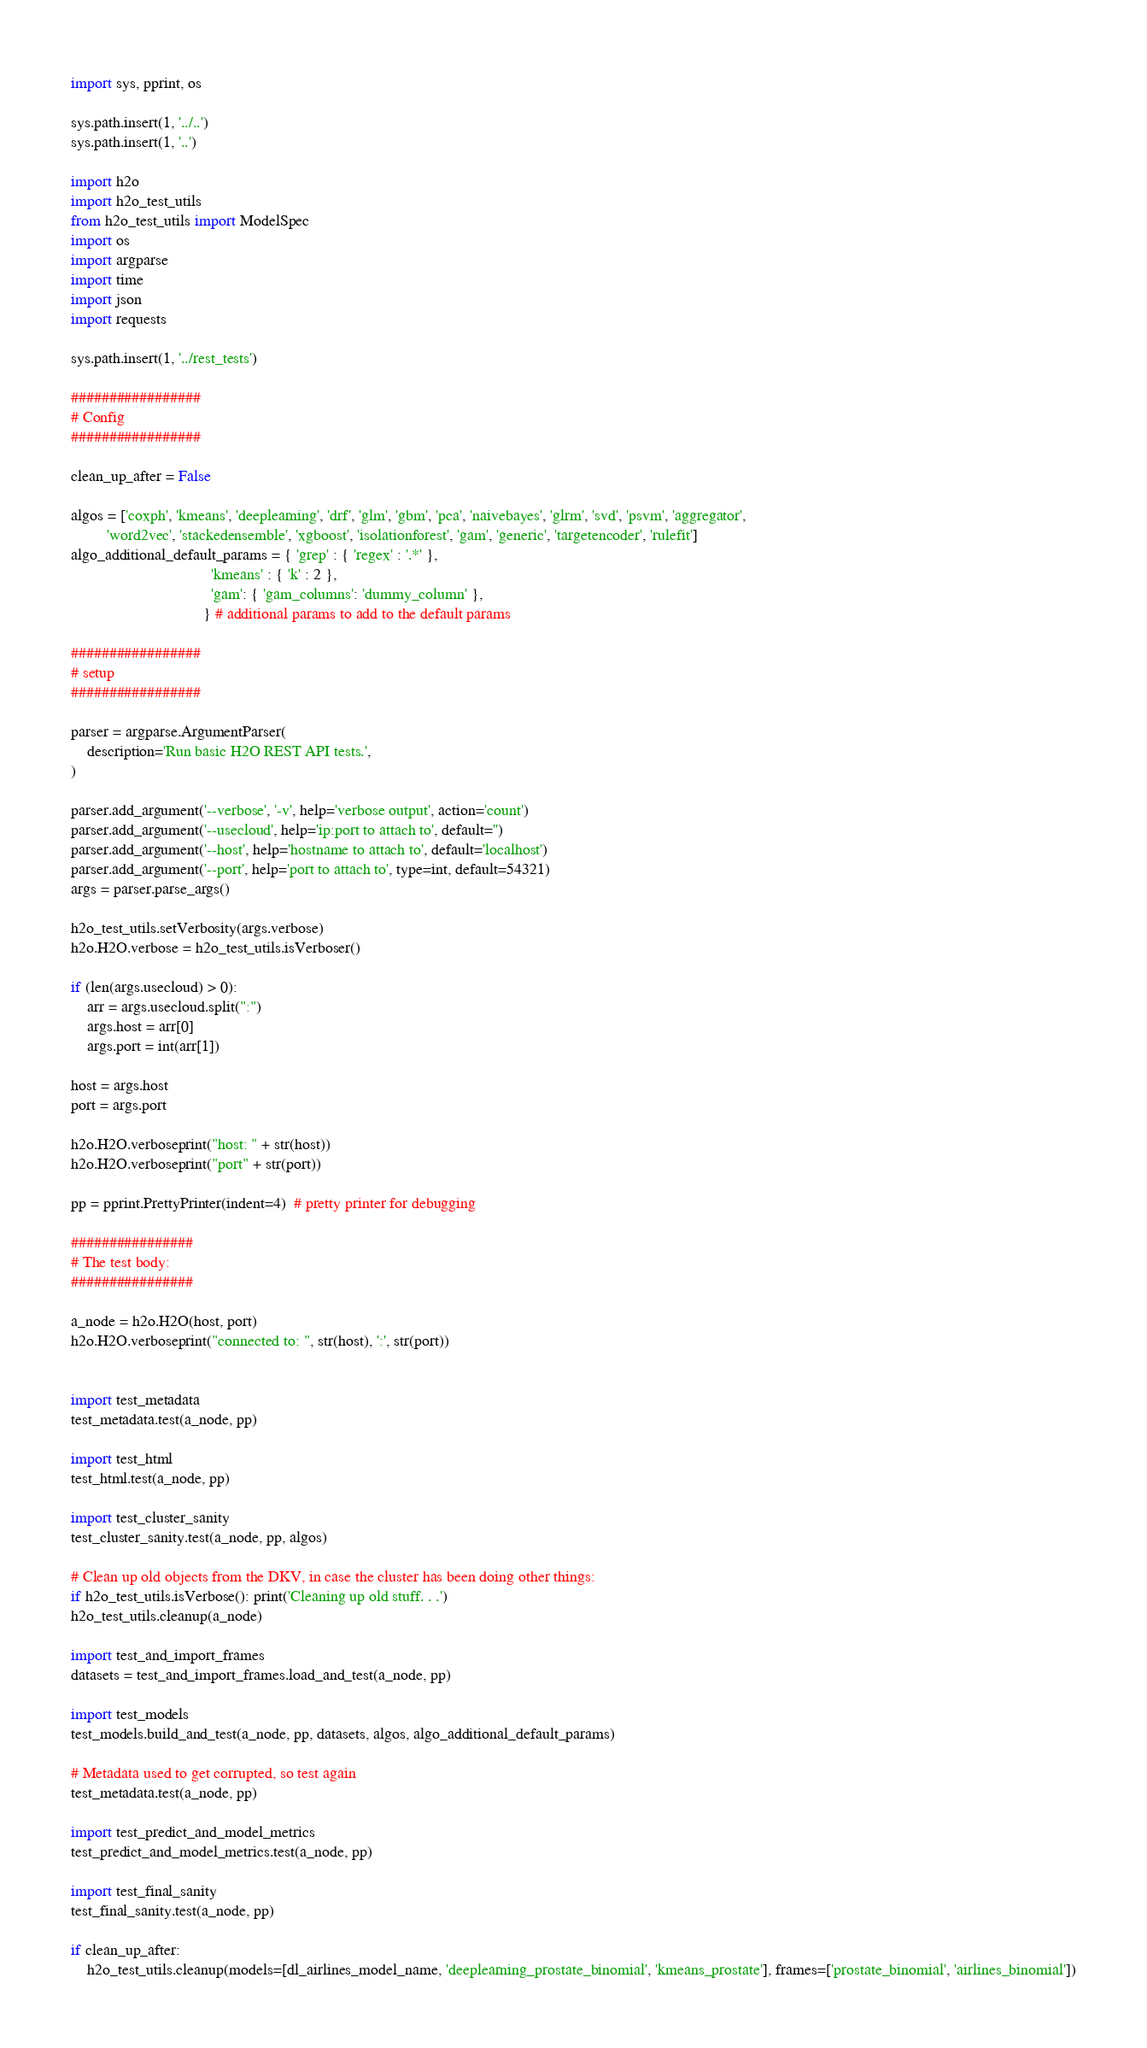<code> <loc_0><loc_0><loc_500><loc_500><_Python_>import sys, pprint, os

sys.path.insert(1, '../..')
sys.path.insert(1, '..')

import h2o
import h2o_test_utils
from h2o_test_utils import ModelSpec
import os
import argparse
import time
import json
import requests

sys.path.insert(1, '../rest_tests')

#################
# Config
#################

clean_up_after = False

algos = ['coxph', 'kmeans', 'deeplearning', 'drf', 'glm', 'gbm', 'pca', 'naivebayes', 'glrm', 'svd', 'psvm', 'aggregator',
         'word2vec', 'stackedensemble', 'xgboost', 'isolationforest', 'gam', 'generic', 'targetencoder', 'rulefit']
algo_additional_default_params = { 'grep' : { 'regex' : '.*' },
                                   'kmeans' : { 'k' : 2 },
                                   'gam': { 'gam_columns': 'dummy_column' },
                                 } # additional params to add to the default params

#################
# setup
#################

parser = argparse.ArgumentParser(
    description='Run basic H2O REST API tests.',
)

parser.add_argument('--verbose', '-v', help='verbose output', action='count')
parser.add_argument('--usecloud', help='ip:port to attach to', default='')
parser.add_argument('--host', help='hostname to attach to', default='localhost')
parser.add_argument('--port', help='port to attach to', type=int, default=54321)
args = parser.parse_args()

h2o_test_utils.setVerbosity(args.verbose)
h2o.H2O.verbose = h2o_test_utils.isVerboser()

if (len(args.usecloud) > 0):
    arr = args.usecloud.split(":")
    args.host = arr[0]
    args.port = int(arr[1])

host = args.host
port = args.port

h2o.H2O.verboseprint("host: " + str(host))
h2o.H2O.verboseprint("port" + str(port))

pp = pprint.PrettyPrinter(indent=4)  # pretty printer for debugging

################
# The test body:
################

a_node = h2o.H2O(host, port)
h2o.H2O.verboseprint("connected to: ", str(host), ':', str(port))


import test_metadata
test_metadata.test(a_node, pp)

import test_html
test_html.test(a_node, pp)

import test_cluster_sanity
test_cluster_sanity.test(a_node, pp, algos)

# Clean up old objects from the DKV, in case the cluster has been doing other things:
if h2o_test_utils.isVerbose(): print('Cleaning up old stuff. . .')
h2o_test_utils.cleanup(a_node)

import test_and_import_frames
datasets = test_and_import_frames.load_and_test(a_node, pp)

import test_models
test_models.build_and_test(a_node, pp, datasets, algos, algo_additional_default_params)

# Metadata used to get corrupted, so test again
test_metadata.test(a_node, pp)

import test_predict_and_model_metrics
test_predict_and_model_metrics.test(a_node, pp)

import test_final_sanity
test_final_sanity.test(a_node, pp)

if clean_up_after:
    h2o_test_utils.cleanup(models=[dl_airlines_model_name, 'deeplearning_prostate_binomial', 'kmeans_prostate'], frames=['prostate_binomial', 'airlines_binomial'])


</code> 